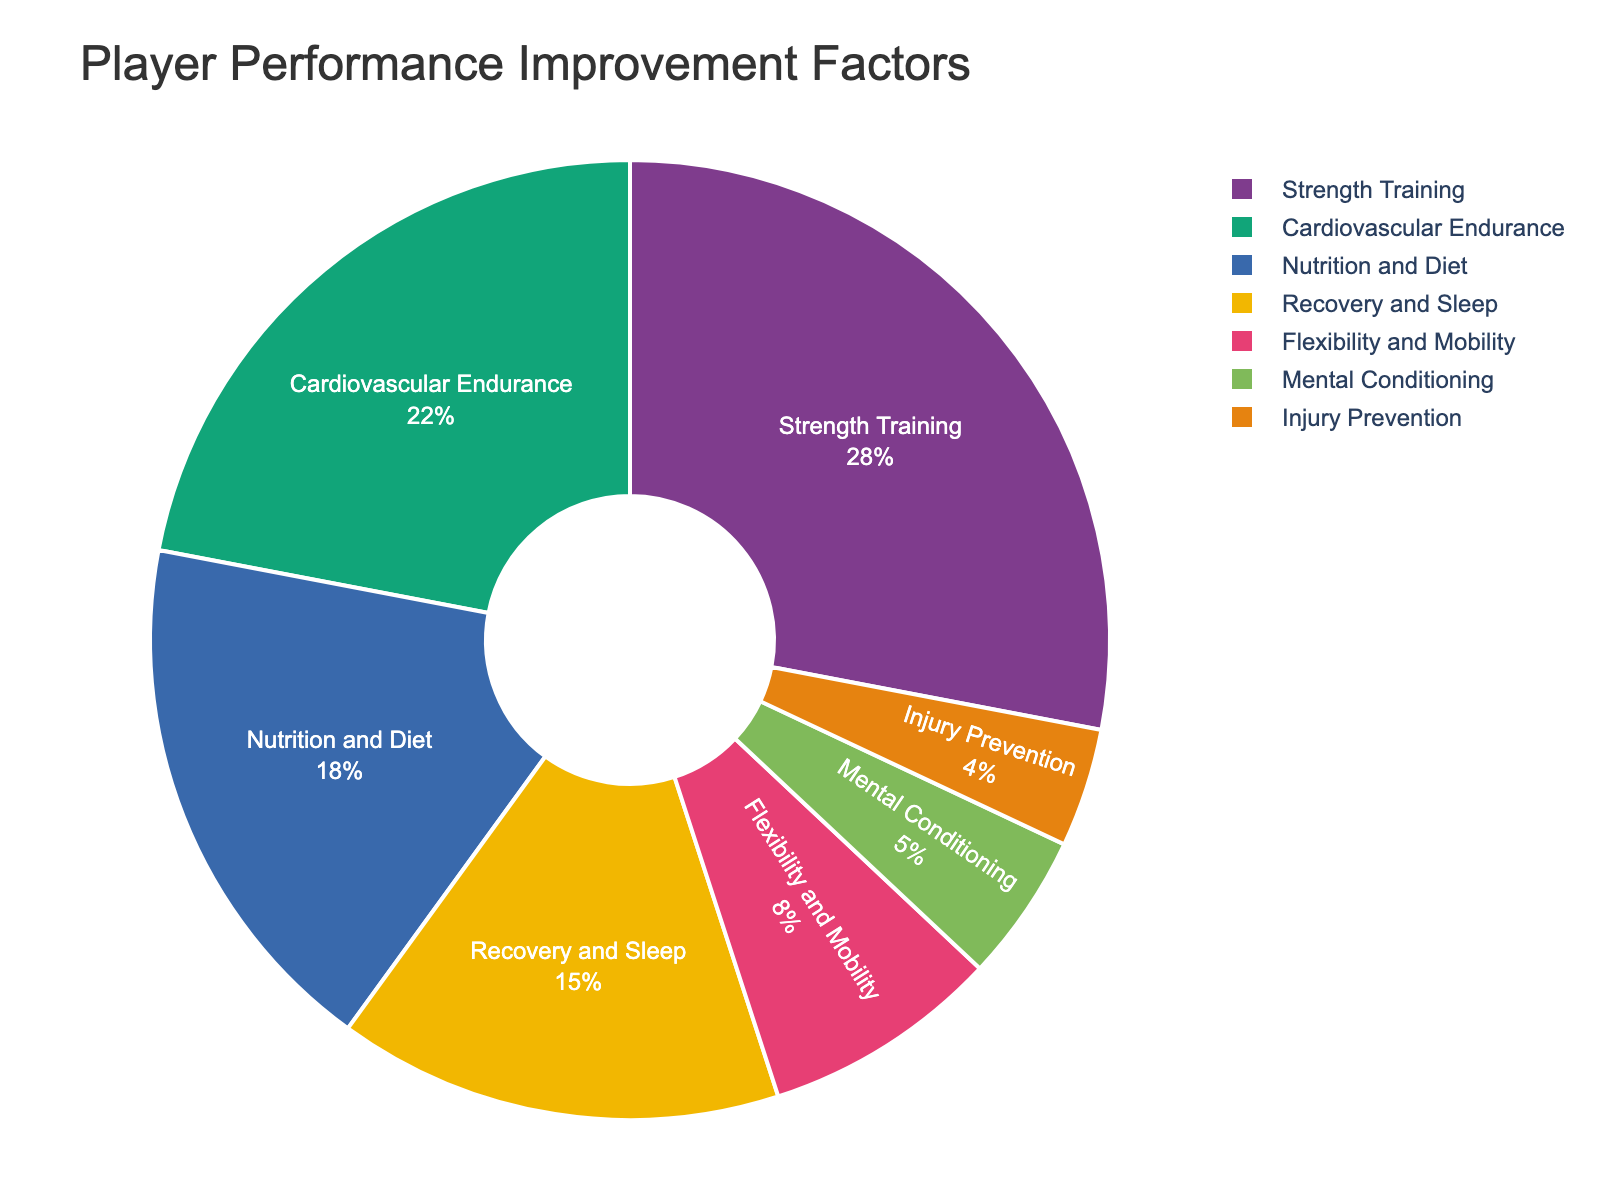What's the largest factor contributing to player performance improvement? The pie chart shows the different factors contributing to player performance improvement with their corresponding percentages. The factor with the highest percentage is the largest contributor. The biggest percentage is 28%, which corresponds to Strength Training
Answer: Strength Training Which two factors combined make up the largest portion of the chart? To determine the two factors that make up the largest portion, we add the percentages of the top two contributing factors. Strength Training (28%) + Cardiovascular Endurance (22%) = 50%
Answer: Strength Training and Cardiovascular Endurance How much more does Nutrition and Diet contribute compared to Injury Prevention? Check the percentages for both Nutrition and Diet and Injury Prevention. Then, subtract Injury Prevention's percentage from Nutrition and Diet's percentage. 18% - 4% = 14%
Answer: 14% What's the difference in percentages between Cardiovascular Endurance and Flexibility and Mobility? Identify the percentages for both factors from the pie chart. Subtract the percentage of Flexibility and Mobility from Cardiovascular Endurance: 22% - 8% = 14%
Answer: 14% Which conditioning factor is represented in the smallest slice of the pie chart? The pie chart shows several factors with their respective percentages. The smallest slice corresponds to the smallest percentage, which is 4% for Injury Prevention
Answer: Injury Prevention How do Recovery and Sleep and Mental Conditioning together contribute to player improvement? Add the percentages of Recovery and Sleep and Mental Conditioning: 15% + 5% = 20%
Answer: 20% What is the combined contribution of Flexibility and Mobility, and Injury Prevention? Sum the percentages of Flexibility and Mobility and Injury Prevention: 8% + 4% = 12%
Answer: 12% Which factor has a larger contribution, Recovery and Sleep or Nutrition and Diet, and by how much? Compare the percentages of Recovery and Sleep (15%) and Nutrition and Diet (18%). Calculate the difference: 18% - 15% = 3%
Answer: Nutrition and Diet by 3% 